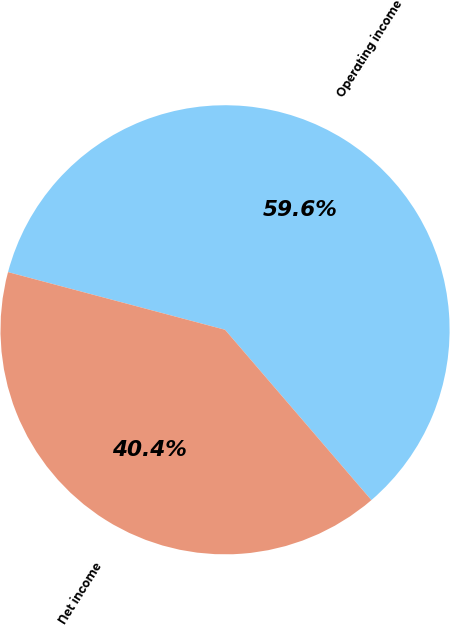Convert chart. <chart><loc_0><loc_0><loc_500><loc_500><pie_chart><fcel>Operating income<fcel>Net income<nl><fcel>59.57%<fcel>40.43%<nl></chart> 